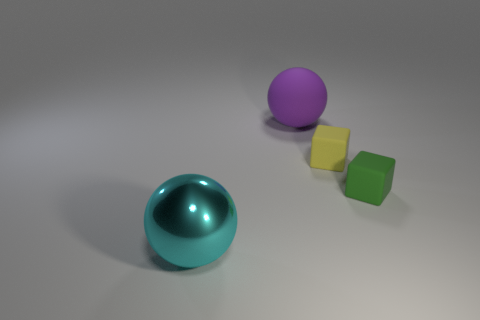How many big things are either shiny things or cubes?
Give a very brief answer. 1. What is the cyan object made of?
Provide a short and direct response. Metal. The thing that is on the left side of the small yellow object and in front of the big purple object is made of what material?
Your response must be concise. Metal. What material is the object that is the same size as the cyan ball?
Offer a terse response. Rubber. Are there any other balls made of the same material as the large purple ball?
Make the answer very short. No. How many big things are there?
Provide a short and direct response. 2. Are the purple sphere and the big sphere that is in front of the purple object made of the same material?
Offer a very short reply. No. How many other spheres are the same color as the large shiny ball?
Offer a terse response. 0. What is the size of the yellow object?
Keep it short and to the point. Small. There is a purple object; does it have the same shape as the tiny rubber thing that is in front of the yellow object?
Provide a short and direct response. No. 